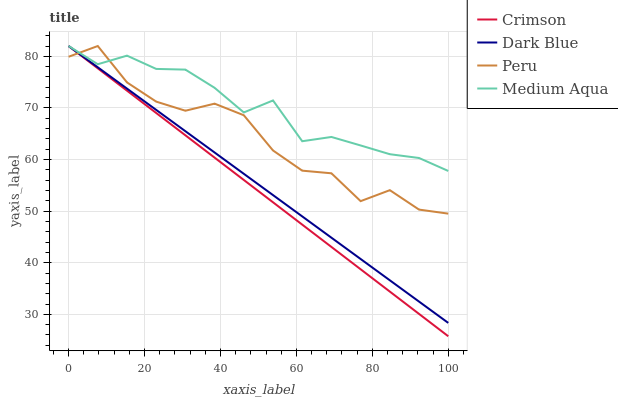Does Crimson have the minimum area under the curve?
Answer yes or no. Yes. Does Medium Aqua have the maximum area under the curve?
Answer yes or no. Yes. Does Dark Blue have the minimum area under the curve?
Answer yes or no. No. Does Dark Blue have the maximum area under the curve?
Answer yes or no. No. Is Dark Blue the smoothest?
Answer yes or no. Yes. Is Peru the roughest?
Answer yes or no. Yes. Is Medium Aqua the smoothest?
Answer yes or no. No. Is Medium Aqua the roughest?
Answer yes or no. No. Does Dark Blue have the lowest value?
Answer yes or no. No. Does Peru have the highest value?
Answer yes or no. Yes. Does Peru intersect Crimson?
Answer yes or no. Yes. Is Peru less than Crimson?
Answer yes or no. No. Is Peru greater than Crimson?
Answer yes or no. No. 